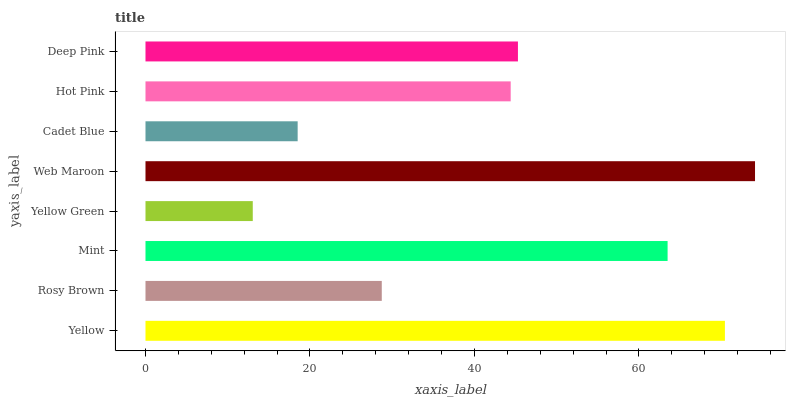Is Yellow Green the minimum?
Answer yes or no. Yes. Is Web Maroon the maximum?
Answer yes or no. Yes. Is Rosy Brown the minimum?
Answer yes or no. No. Is Rosy Brown the maximum?
Answer yes or no. No. Is Yellow greater than Rosy Brown?
Answer yes or no. Yes. Is Rosy Brown less than Yellow?
Answer yes or no. Yes. Is Rosy Brown greater than Yellow?
Answer yes or no. No. Is Yellow less than Rosy Brown?
Answer yes or no. No. Is Deep Pink the high median?
Answer yes or no. Yes. Is Hot Pink the low median?
Answer yes or no. Yes. Is Web Maroon the high median?
Answer yes or no. No. Is Yellow the low median?
Answer yes or no. No. 